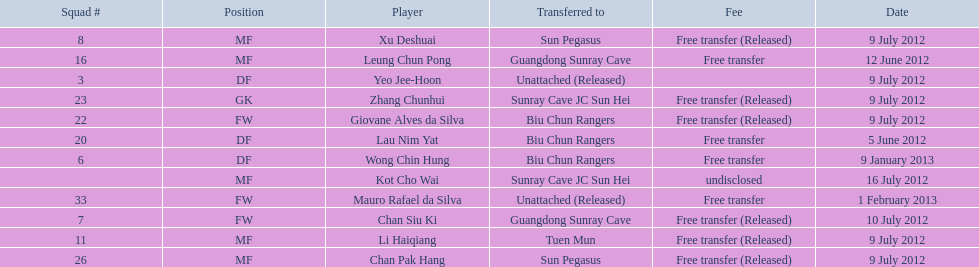Player transferred immediately before mauro rafael da silva Wong Chin Hung. 